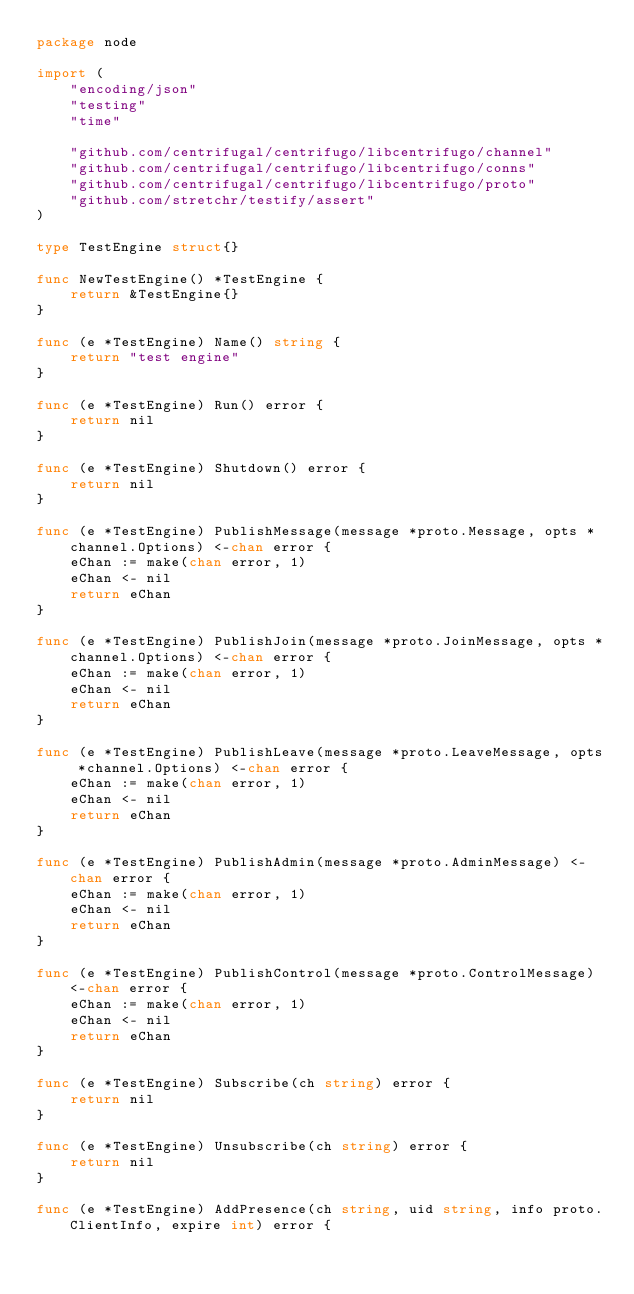Convert code to text. <code><loc_0><loc_0><loc_500><loc_500><_Go_>package node

import (
	"encoding/json"
	"testing"
	"time"

	"github.com/centrifugal/centrifugo/libcentrifugo/channel"
	"github.com/centrifugal/centrifugo/libcentrifugo/conns"
	"github.com/centrifugal/centrifugo/libcentrifugo/proto"
	"github.com/stretchr/testify/assert"
)

type TestEngine struct{}

func NewTestEngine() *TestEngine {
	return &TestEngine{}
}

func (e *TestEngine) Name() string {
	return "test engine"
}

func (e *TestEngine) Run() error {
	return nil
}

func (e *TestEngine) Shutdown() error {
	return nil
}

func (e *TestEngine) PublishMessage(message *proto.Message, opts *channel.Options) <-chan error {
	eChan := make(chan error, 1)
	eChan <- nil
	return eChan
}

func (e *TestEngine) PublishJoin(message *proto.JoinMessage, opts *channel.Options) <-chan error {
	eChan := make(chan error, 1)
	eChan <- nil
	return eChan
}

func (e *TestEngine) PublishLeave(message *proto.LeaveMessage, opts *channel.Options) <-chan error {
	eChan := make(chan error, 1)
	eChan <- nil
	return eChan
}

func (e *TestEngine) PublishAdmin(message *proto.AdminMessage) <-chan error {
	eChan := make(chan error, 1)
	eChan <- nil
	return eChan
}

func (e *TestEngine) PublishControl(message *proto.ControlMessage) <-chan error {
	eChan := make(chan error, 1)
	eChan <- nil
	return eChan
}

func (e *TestEngine) Subscribe(ch string) error {
	return nil
}

func (e *TestEngine) Unsubscribe(ch string) error {
	return nil
}

func (e *TestEngine) AddPresence(ch string, uid string, info proto.ClientInfo, expire int) error {</code> 